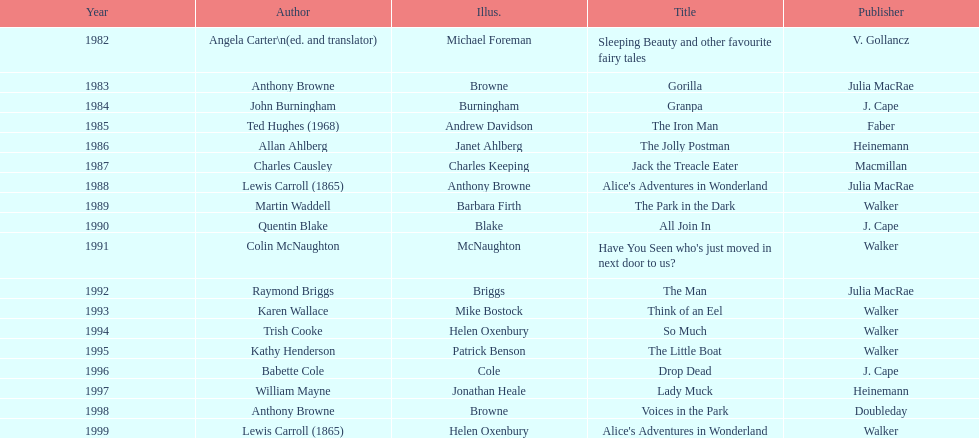What is the only title listed for 1999? Alice's Adventures in Wonderland. 